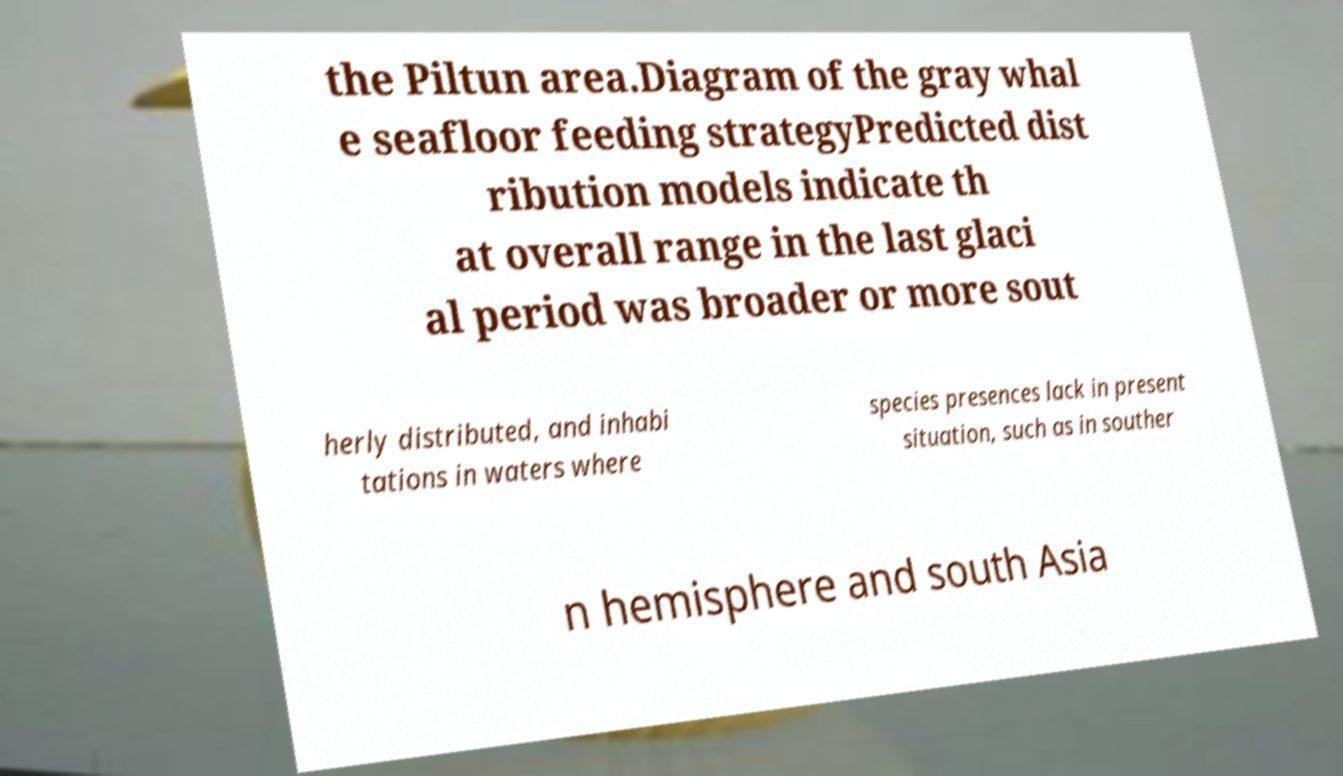Please read and relay the text visible in this image. What does it say? the Piltun area.Diagram of the gray whal e seafloor feeding strategyPredicted dist ribution models indicate th at overall range in the last glaci al period was broader or more sout herly distributed, and inhabi tations in waters where species presences lack in present situation, such as in souther n hemisphere and south Asia 